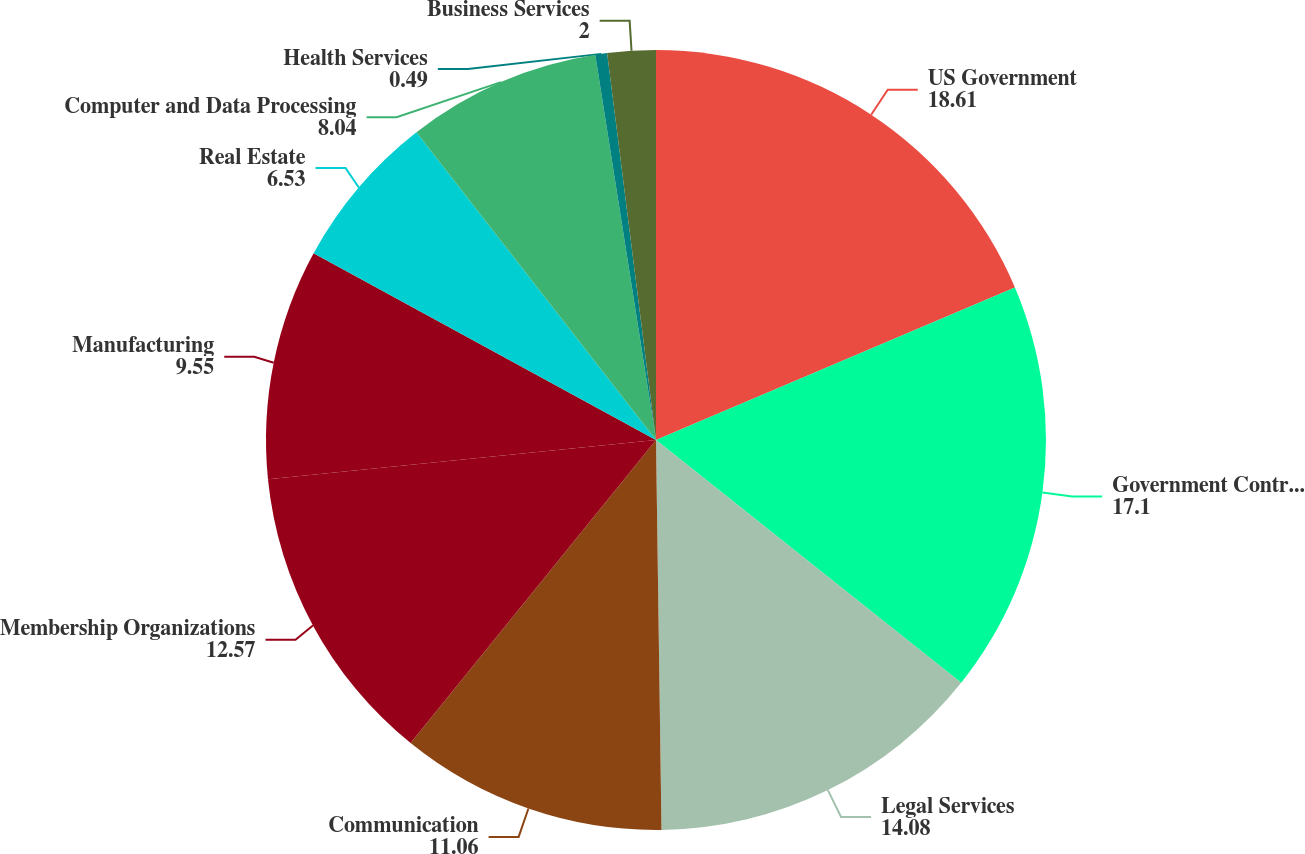Convert chart to OTSL. <chart><loc_0><loc_0><loc_500><loc_500><pie_chart><fcel>US Government<fcel>Government Contractors<fcel>Legal Services<fcel>Communication<fcel>Membership Organizations<fcel>Manufacturing<fcel>Real Estate<fcel>Computer and Data Processing<fcel>Health Services<fcel>Business Services<nl><fcel>18.61%<fcel>17.1%<fcel>14.08%<fcel>11.06%<fcel>12.57%<fcel>9.55%<fcel>6.53%<fcel>8.04%<fcel>0.49%<fcel>2.0%<nl></chart> 